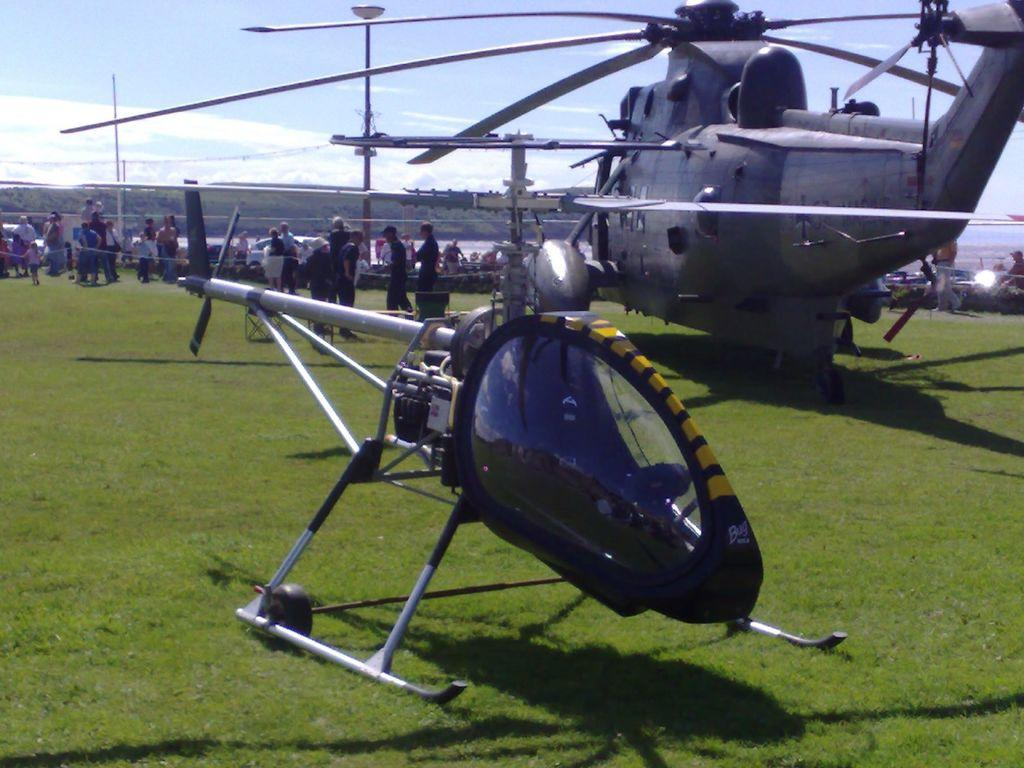What is the main subject of the image? The main subject of the image is two airplanes in the center. What can be seen in the background of the image? The sky, clouds, plants, grass, vehicles, and people are visible in the background of the image. What type of boot is being worn by the airplane in the image? There are no boots present in the image, as it features airplanes and various background elements. 